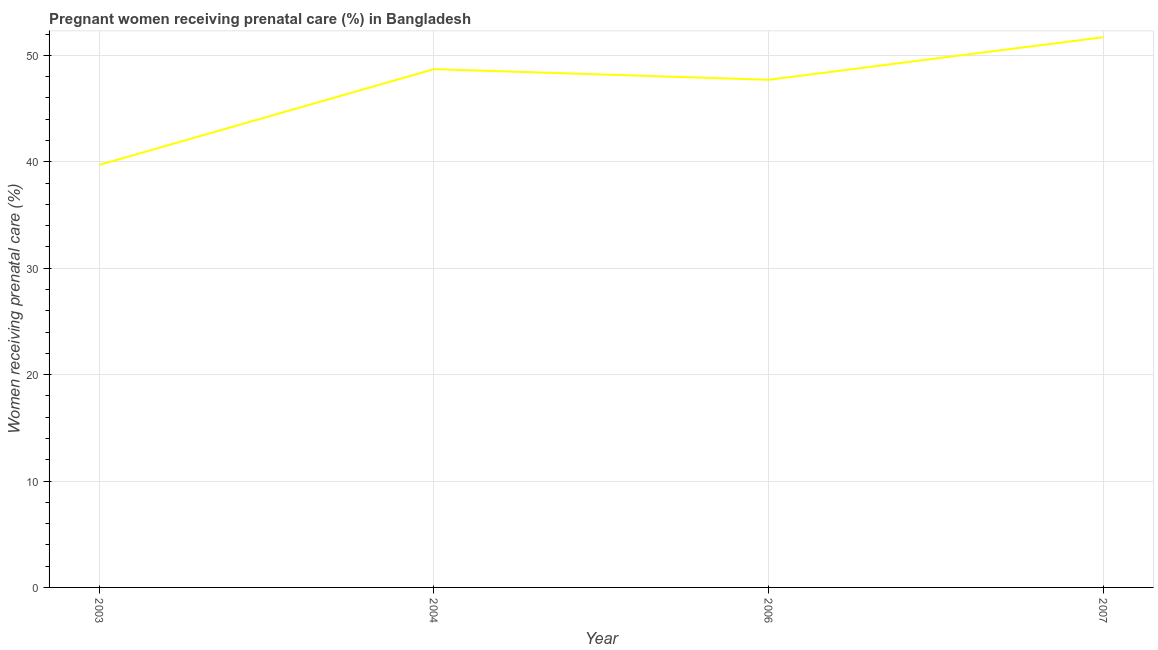What is the percentage of pregnant women receiving prenatal care in 2003?
Your response must be concise. 39.7. Across all years, what is the maximum percentage of pregnant women receiving prenatal care?
Provide a short and direct response. 51.7. Across all years, what is the minimum percentage of pregnant women receiving prenatal care?
Give a very brief answer. 39.7. In which year was the percentage of pregnant women receiving prenatal care maximum?
Make the answer very short. 2007. What is the sum of the percentage of pregnant women receiving prenatal care?
Offer a very short reply. 187.8. What is the average percentage of pregnant women receiving prenatal care per year?
Ensure brevity in your answer.  46.95. What is the median percentage of pregnant women receiving prenatal care?
Give a very brief answer. 48.2. In how many years, is the percentage of pregnant women receiving prenatal care greater than 38 %?
Your response must be concise. 4. What is the ratio of the percentage of pregnant women receiving prenatal care in 2004 to that in 2006?
Your response must be concise. 1.02. Is the difference between the percentage of pregnant women receiving prenatal care in 2006 and 2007 greater than the difference between any two years?
Provide a short and direct response. No. What is the difference between the highest and the second highest percentage of pregnant women receiving prenatal care?
Keep it short and to the point. 3. Is the sum of the percentage of pregnant women receiving prenatal care in 2003 and 2007 greater than the maximum percentage of pregnant women receiving prenatal care across all years?
Keep it short and to the point. Yes. What is the difference between the highest and the lowest percentage of pregnant women receiving prenatal care?
Make the answer very short. 12. In how many years, is the percentage of pregnant women receiving prenatal care greater than the average percentage of pregnant women receiving prenatal care taken over all years?
Your answer should be compact. 3. Does the percentage of pregnant women receiving prenatal care monotonically increase over the years?
Provide a short and direct response. No. Are the values on the major ticks of Y-axis written in scientific E-notation?
Provide a succinct answer. No. Does the graph contain grids?
Offer a terse response. Yes. What is the title of the graph?
Provide a succinct answer. Pregnant women receiving prenatal care (%) in Bangladesh. What is the label or title of the Y-axis?
Provide a short and direct response. Women receiving prenatal care (%). What is the Women receiving prenatal care (%) in 2003?
Your response must be concise. 39.7. What is the Women receiving prenatal care (%) of 2004?
Provide a succinct answer. 48.7. What is the Women receiving prenatal care (%) in 2006?
Provide a short and direct response. 47.7. What is the Women receiving prenatal care (%) of 2007?
Make the answer very short. 51.7. What is the difference between the Women receiving prenatal care (%) in 2003 and 2004?
Give a very brief answer. -9. What is the difference between the Women receiving prenatal care (%) in 2003 and 2006?
Keep it short and to the point. -8. What is the difference between the Women receiving prenatal care (%) in 2004 and 2006?
Your answer should be very brief. 1. What is the difference between the Women receiving prenatal care (%) in 2004 and 2007?
Make the answer very short. -3. What is the difference between the Women receiving prenatal care (%) in 2006 and 2007?
Your response must be concise. -4. What is the ratio of the Women receiving prenatal care (%) in 2003 to that in 2004?
Make the answer very short. 0.81. What is the ratio of the Women receiving prenatal care (%) in 2003 to that in 2006?
Provide a short and direct response. 0.83. What is the ratio of the Women receiving prenatal care (%) in 2003 to that in 2007?
Give a very brief answer. 0.77. What is the ratio of the Women receiving prenatal care (%) in 2004 to that in 2007?
Your response must be concise. 0.94. What is the ratio of the Women receiving prenatal care (%) in 2006 to that in 2007?
Ensure brevity in your answer.  0.92. 